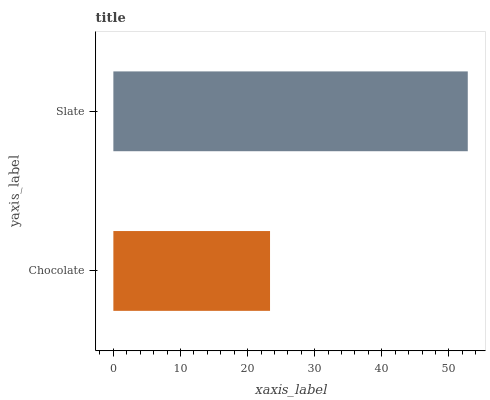Is Chocolate the minimum?
Answer yes or no. Yes. Is Slate the maximum?
Answer yes or no. Yes. Is Slate the minimum?
Answer yes or no. No. Is Slate greater than Chocolate?
Answer yes or no. Yes. Is Chocolate less than Slate?
Answer yes or no. Yes. Is Chocolate greater than Slate?
Answer yes or no. No. Is Slate less than Chocolate?
Answer yes or no. No. Is Slate the high median?
Answer yes or no. Yes. Is Chocolate the low median?
Answer yes or no. Yes. Is Chocolate the high median?
Answer yes or no. No. Is Slate the low median?
Answer yes or no. No. 